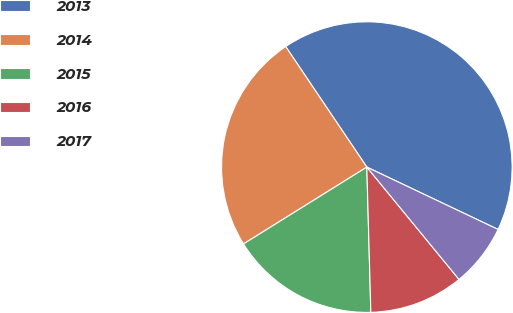Convert chart to OTSL. <chart><loc_0><loc_0><loc_500><loc_500><pie_chart><fcel>2013<fcel>2014<fcel>2015<fcel>2016<fcel>2017<nl><fcel>41.49%<fcel>24.44%<fcel>16.57%<fcel>10.5%<fcel>7.0%<nl></chart> 